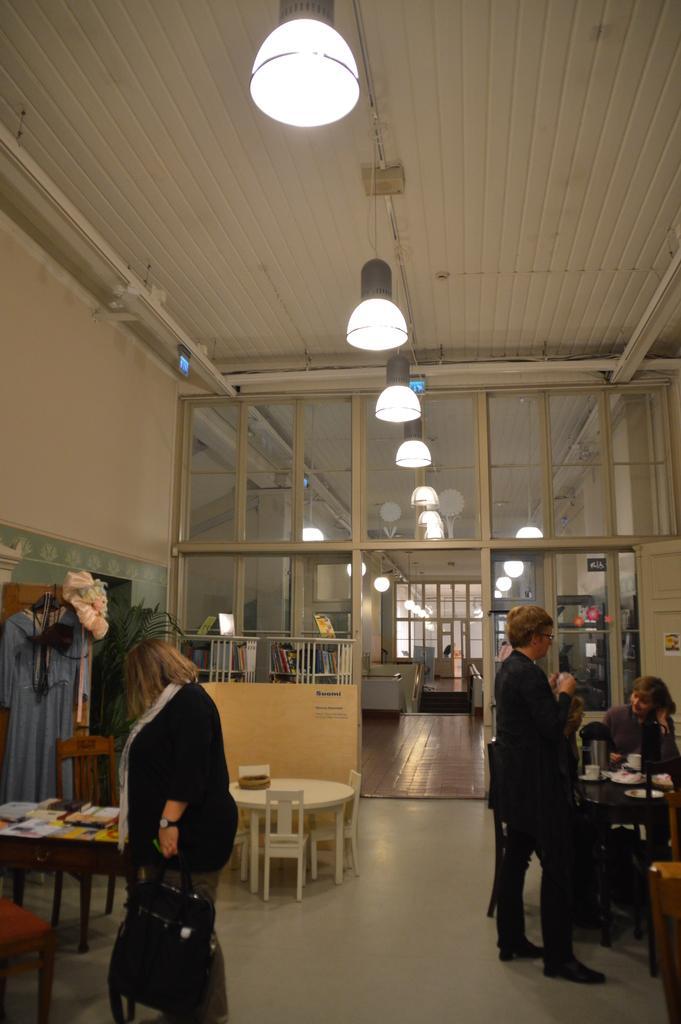Can you describe this image briefly? In this image there is a woman standing on the floor holding a bag. Beside her a man standing in black coat in front of him ,some peoples are sitting on the chairs and there is a table on that some food items are there is a glass window above that there is a roof on which lights are hanging 